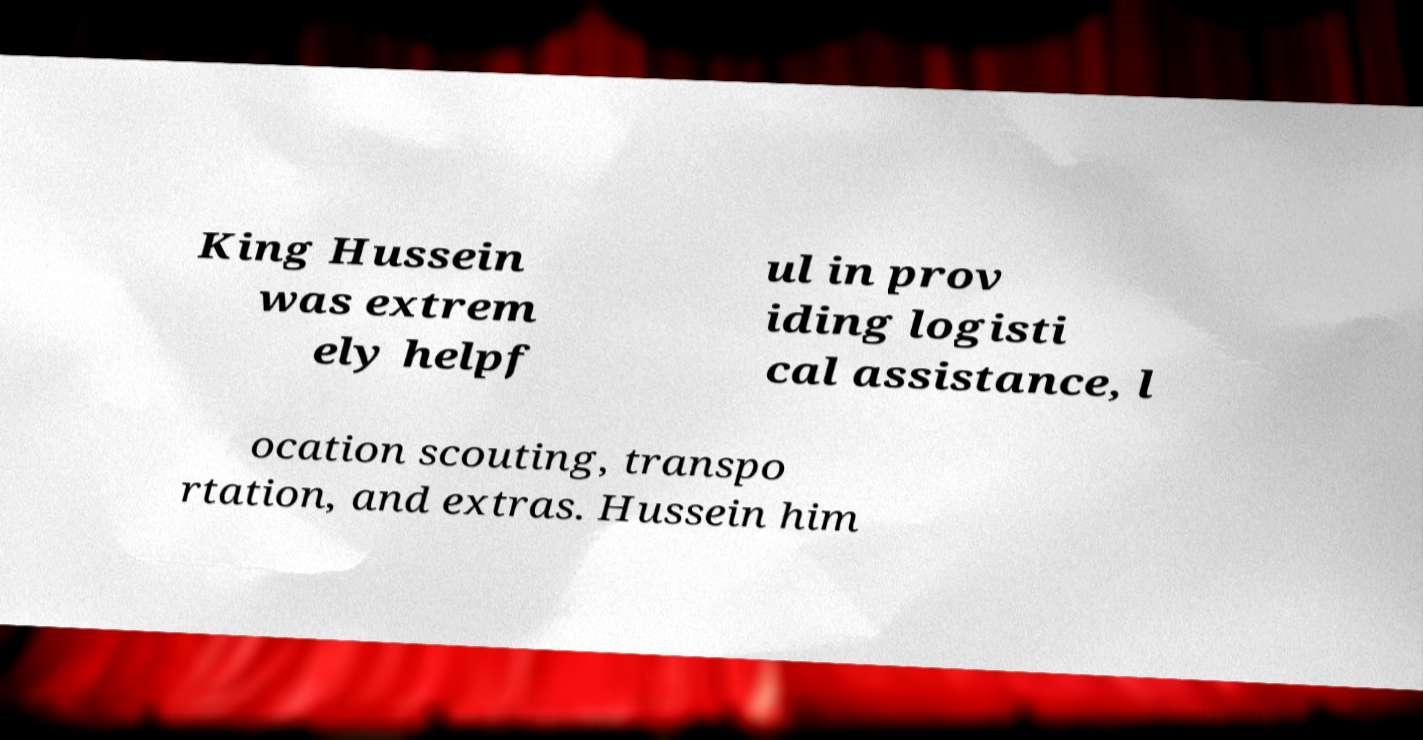I need the written content from this picture converted into text. Can you do that? King Hussein was extrem ely helpf ul in prov iding logisti cal assistance, l ocation scouting, transpo rtation, and extras. Hussein him 